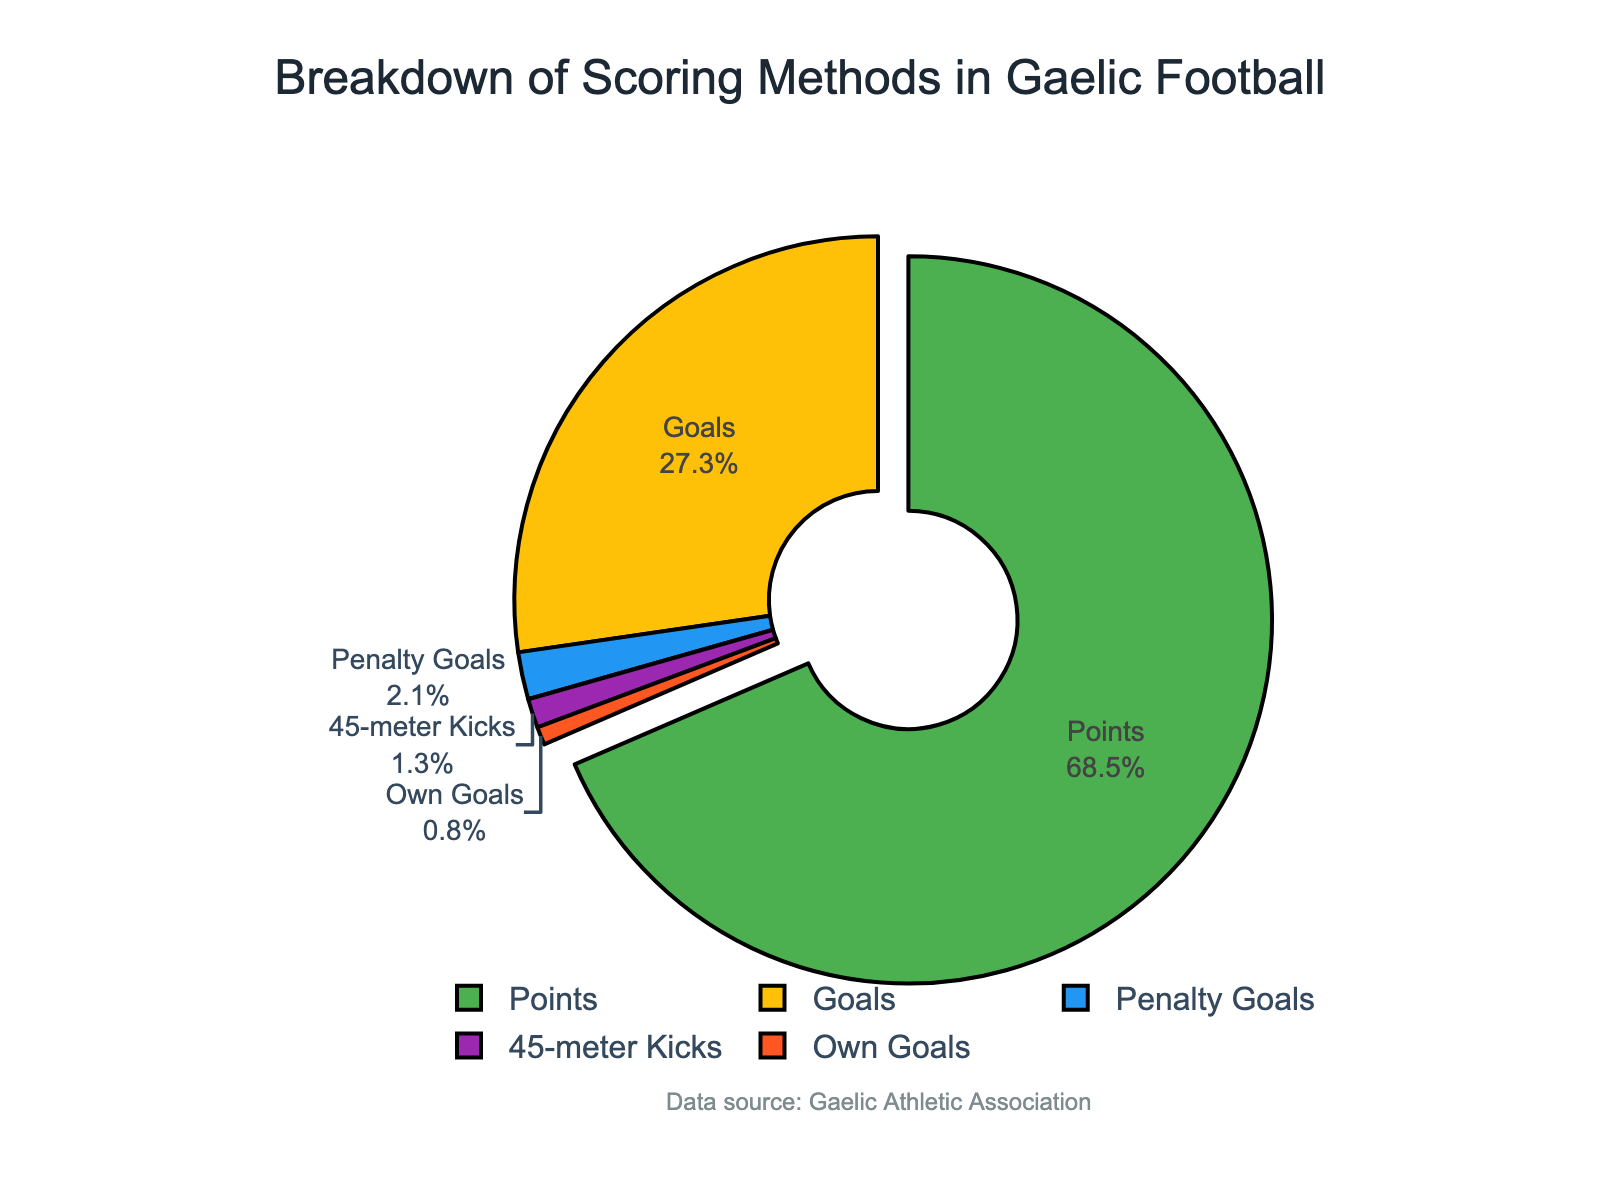Which scoring method has the highest percentage? The slice with the largest area in the pie chart corresponds to the 'Points' scoring method. Generally, the segment with the label showing the highest percentage indicates the most dominant category.
Answer: Points What's the combined percentage of Goals and Penalty Goals? The percentage for Goals is 27.3% and for Penalty Goals is 2.1%. Adding these two percentages together gives: 27.3 + 2.1 = 29.4%
Answer: 29.4% How much more common are Points compared to Own Goals? The percentage for Points is 68.5% and for Own Goals is 0.8%. To find how much more common Points are compared to Own Goals, subtract the percentage for Own Goals from the percentage for Points: 68.5 - 0.8 = 67.7%
Answer: 67.7% What fraction of the scoring methods are Penalty Goals and 45-meter Kicks combined? The percentage for Penalty Goals is 2.1% and for 45-meter Kicks is 1.3%. Adding the two gives 3.4%. To convert this into a fraction of the total 100%, divide by 100: 3.4 / 100 = 0.034, which can be expressed as the fraction 34/1000 or simplified to 17/500.
Answer: 17/500 Which color represents Own Goals on the pie chart? Even without seeing the exact pie chart, one can deduce that a distinct color is assigned to each scoring method. Given the order of methods and the corresponding colors, including black lines on each segment, Own Goals might typically use a less prominent color like a shade of orange or similar.
Answer: Typically orange (assuming the order followed in the code) What's the difference in percentage between Goals and 45-meter Kicks? The percentage for Goals is 27.3% and for 45-meter Kicks is 1.3%. Subtract the percentage for 45-meter Kicks from the percentage for Goals: 27.3 - 1.3 = 26%
Answer: 26% How much of the total percentage do methods other than Points account for? The percentage for Points is 68.5%. To find the combined percentage of other methods, subtract this from 100%: 100 - 68.5 = 31.5%
Answer: 31.5% What is the least common scoring method? The smallest slice in the pie chart, identified by the label and the smallest percentage, corresponds to 'Own Goals' which has a percentage of 0.8%.
Answer: Own Goals 